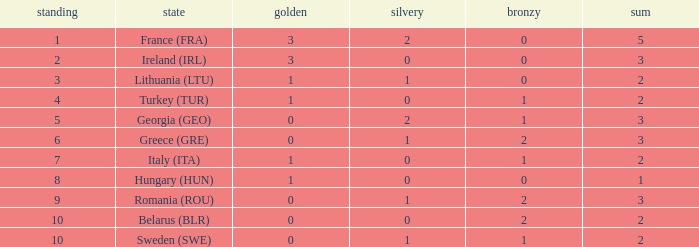What are the most bronze medals in a rank more than 1 with a total larger than 3? None. 